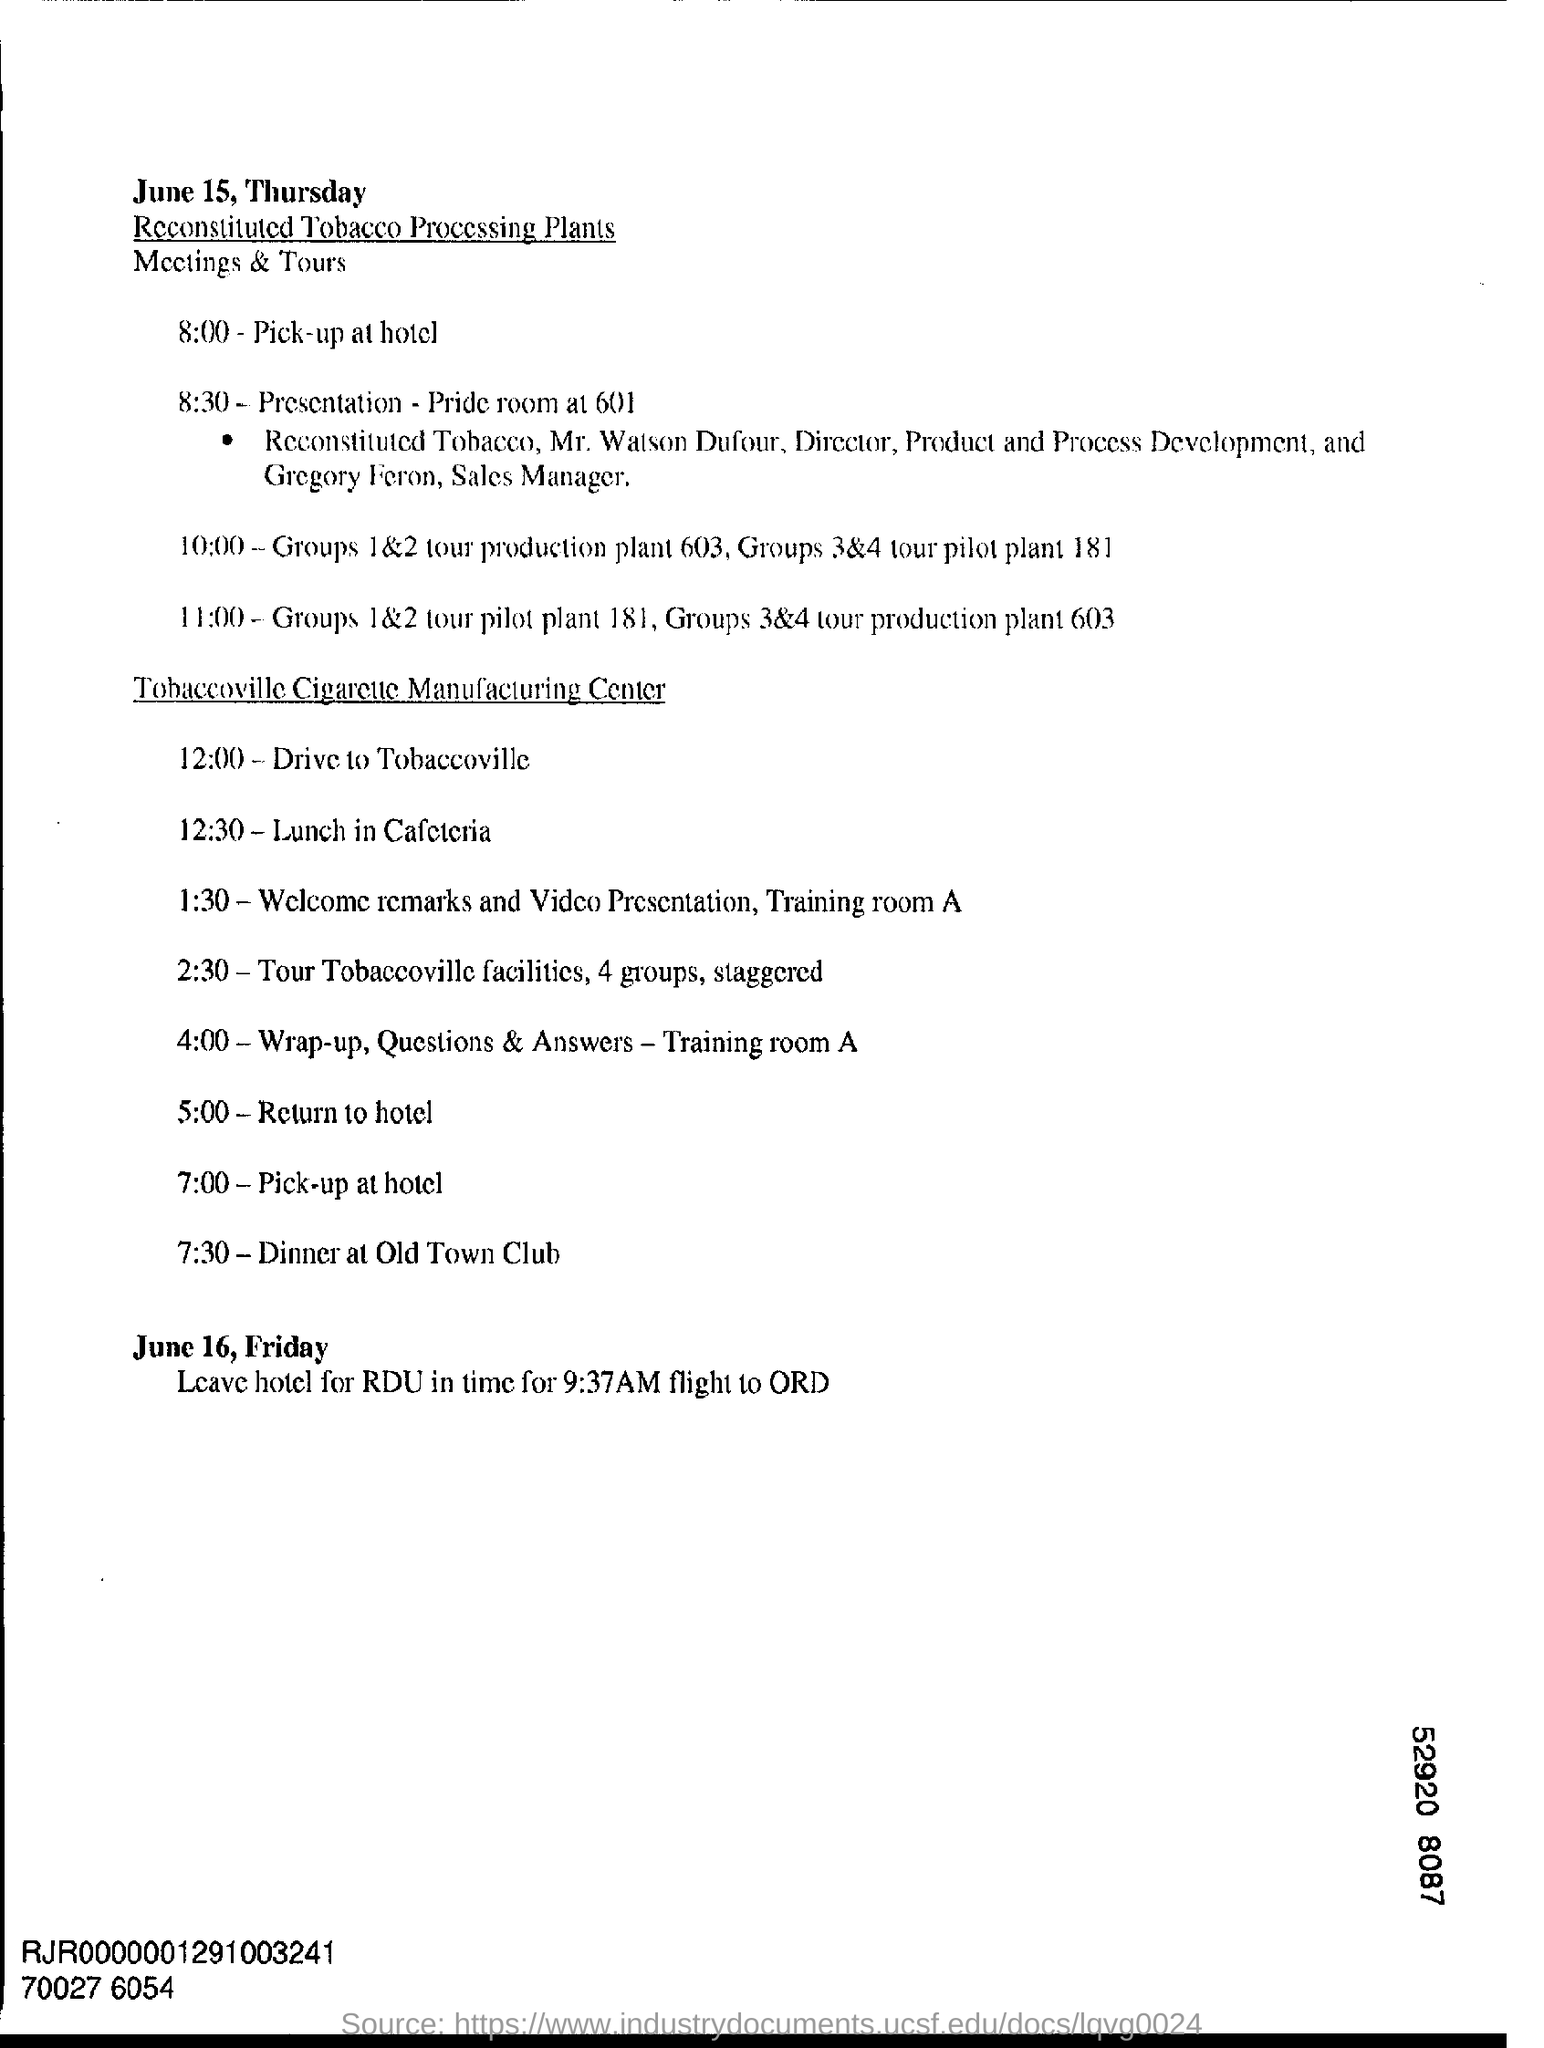Highlight a few significant elements in this photo. The date mentioned at the beginning of this document is June 15, which is a Thursday. The pick-up time at the hotel at the manufacturing center is 7:00. 